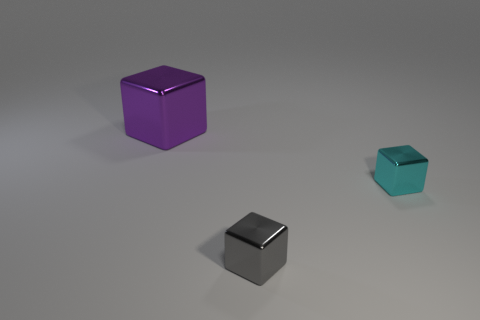There is a cube behind the cyan block; does it have the same size as the gray metal cube?
Provide a short and direct response. No. What size is the object that is in front of the large purple metallic block and left of the tiny cyan metal block?
Your answer should be compact. Small. How many other things are there of the same shape as the purple object?
Your response must be concise. 2. How many other objects are the same material as the large block?
Offer a very short reply. 2. There is a gray metal thing that is the same shape as the large purple thing; what size is it?
Provide a short and direct response. Small. The block that is right of the large purple metal object and behind the gray metallic block is what color?
Offer a very short reply. Cyan. How many objects are either shiny things behind the small gray object or cyan spheres?
Provide a short and direct response. 2. What color is the other big metal thing that is the same shape as the cyan metallic object?
Your response must be concise. Purple. There is a cyan object; is its shape the same as the small thing that is to the left of the cyan metallic block?
Provide a short and direct response. Yes. How many objects are blocks that are right of the large metal block or metallic things that are right of the gray shiny thing?
Your answer should be very brief. 2. 